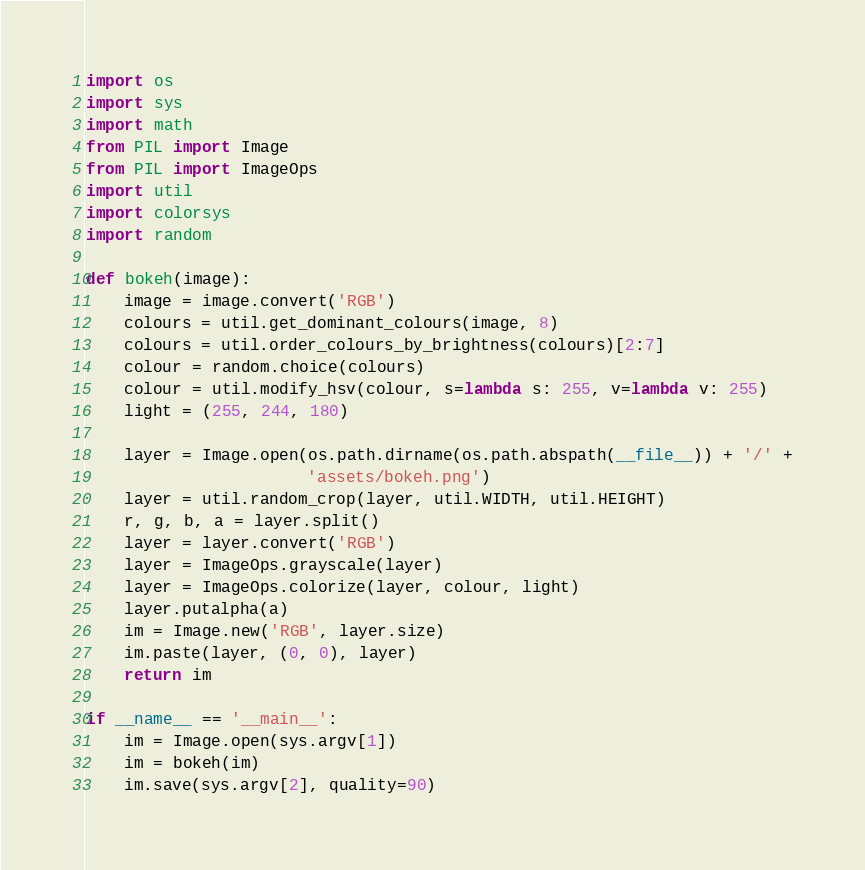<code> <loc_0><loc_0><loc_500><loc_500><_Python_>import os
import sys
import math
from PIL import Image
from PIL import ImageOps
import util
import colorsys
import random

def bokeh(image):
    image = image.convert('RGB')
    colours = util.get_dominant_colours(image, 8)
    colours = util.order_colours_by_brightness(colours)[2:7]
    colour = random.choice(colours)
    colour = util.modify_hsv(colour, s=lambda s: 255, v=lambda v: 255)
    light = (255, 244, 180)

    layer = Image.open(os.path.dirname(os.path.abspath(__file__)) + '/' +
                       'assets/bokeh.png')
    layer = util.random_crop(layer, util.WIDTH, util.HEIGHT)
    r, g, b, a = layer.split()
    layer = layer.convert('RGB')
    layer = ImageOps.grayscale(layer)
    layer = ImageOps.colorize(layer, colour, light)
    layer.putalpha(a)
    im = Image.new('RGB', layer.size)
    im.paste(layer, (0, 0), layer)
    return im

if __name__ == '__main__':
    im = Image.open(sys.argv[1])
    im = bokeh(im)
    im.save(sys.argv[2], quality=90)
</code> 